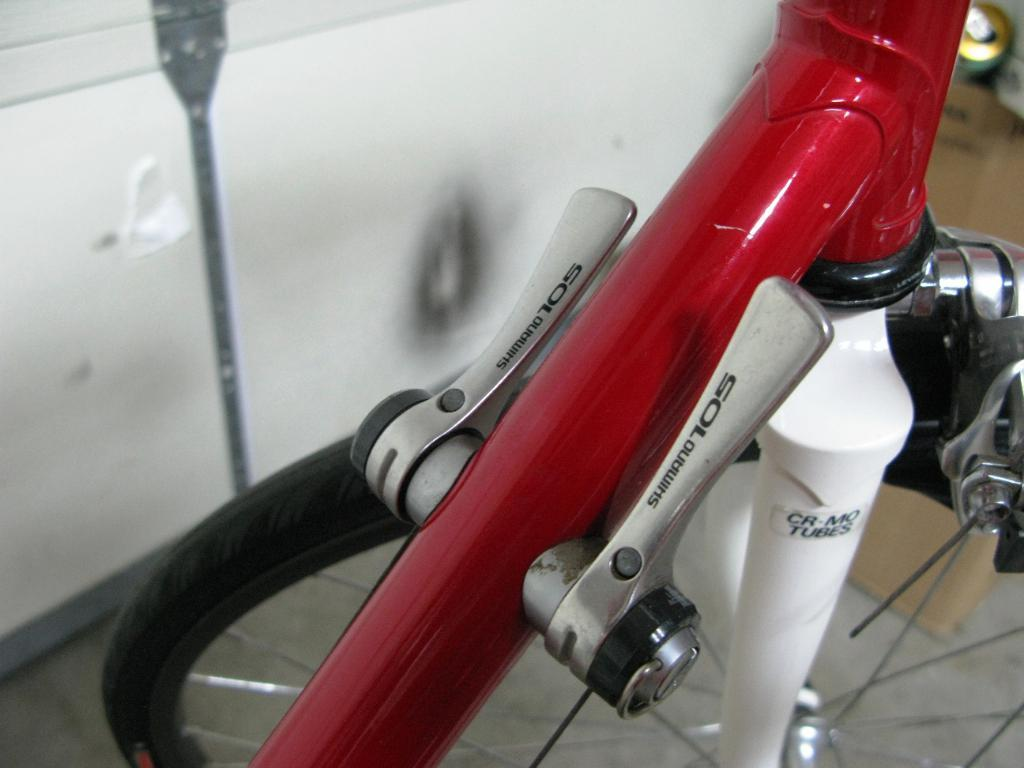What object is partially visible in the image? There is a partial part of a bicycle in the image. Can you describe the background of the image? The background of the image is blurred. What type of leather is used to cover the skin of the bicycle in the image? There is no leather or skin visible in the image, as it only shows a partial part of a bicycle with a blurred background. 